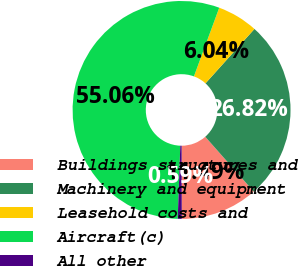<chart> <loc_0><loc_0><loc_500><loc_500><pie_chart><fcel>Buildings structures and<fcel>Machinery and equipment<fcel>Leasehold costs and<fcel>Aircraft(c)<fcel>All other<nl><fcel>11.49%<fcel>26.82%<fcel>6.04%<fcel>55.06%<fcel>0.59%<nl></chart> 